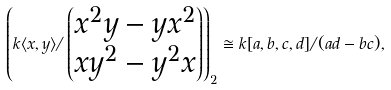<formula> <loc_0><loc_0><loc_500><loc_500>\left ( k \langle x , y \rangle / \begin{pmatrix} x ^ { 2 } y - y x ^ { 2 } \\ x y ^ { 2 } - y ^ { 2 } x \end{pmatrix} \right ) _ { 2 } \cong k [ a , b , c , d ] / ( a d - b c ) ,</formula> 